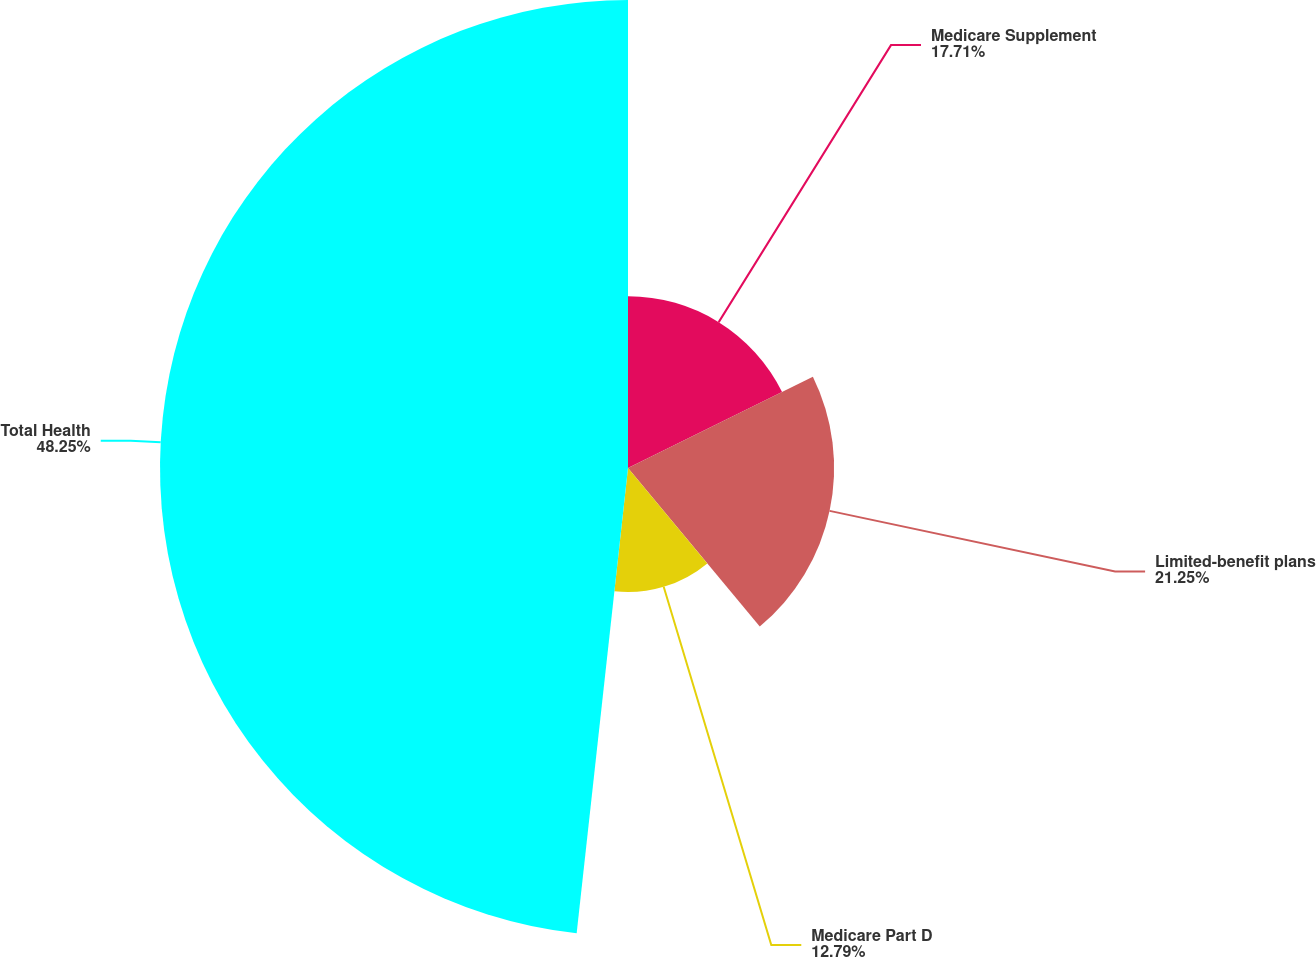<chart> <loc_0><loc_0><loc_500><loc_500><pie_chart><fcel>Medicare Supplement<fcel>Limited-benefit plans<fcel>Medicare Part D<fcel>Total Health<nl><fcel>17.71%<fcel>21.25%<fcel>12.79%<fcel>48.25%<nl></chart> 